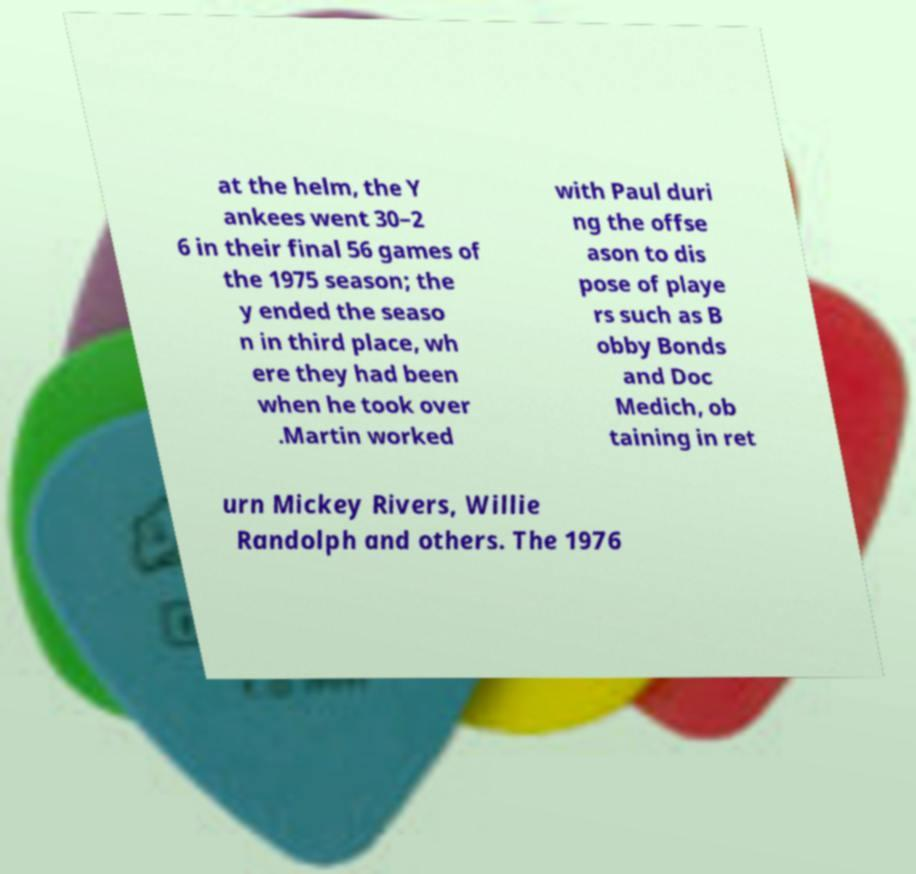There's text embedded in this image that I need extracted. Can you transcribe it verbatim? at the helm, the Y ankees went 30–2 6 in their final 56 games of the 1975 season; the y ended the seaso n in third place, wh ere they had been when he took over .Martin worked with Paul duri ng the offse ason to dis pose of playe rs such as B obby Bonds and Doc Medich, ob taining in ret urn Mickey Rivers, Willie Randolph and others. The 1976 